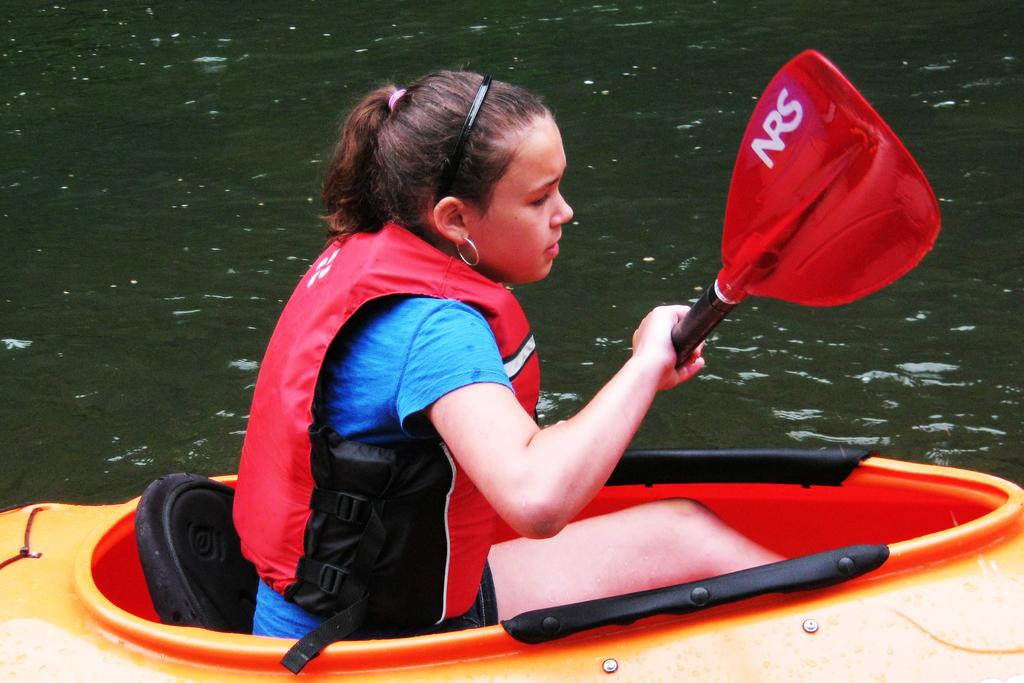Who is present in the image? There is a woman in the image. What is the woman wearing? The woman is wearing a life jacket. What is the woman holding in the image? The woman is holding a stick. Where is the woman sitting? The woman is sitting in a boat. What is the boat placed on? The boat is placed on water. What type of beetle can be seen crawling on the woman's life jacket in the image? There is no beetle present on the woman's life jacket in the image. 